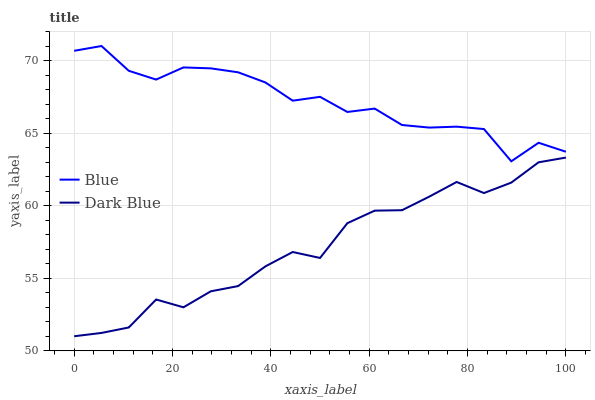Does Dark Blue have the minimum area under the curve?
Answer yes or no. Yes. Does Blue have the maximum area under the curve?
Answer yes or no. Yes. Does Dark Blue have the maximum area under the curve?
Answer yes or no. No. Is Dark Blue the smoothest?
Answer yes or no. Yes. Is Blue the roughest?
Answer yes or no. Yes. Is Dark Blue the roughest?
Answer yes or no. No. Does Dark Blue have the lowest value?
Answer yes or no. Yes. Does Blue have the highest value?
Answer yes or no. Yes. Does Dark Blue have the highest value?
Answer yes or no. No. Is Dark Blue less than Blue?
Answer yes or no. Yes. Is Blue greater than Dark Blue?
Answer yes or no. Yes. Does Dark Blue intersect Blue?
Answer yes or no. No. 